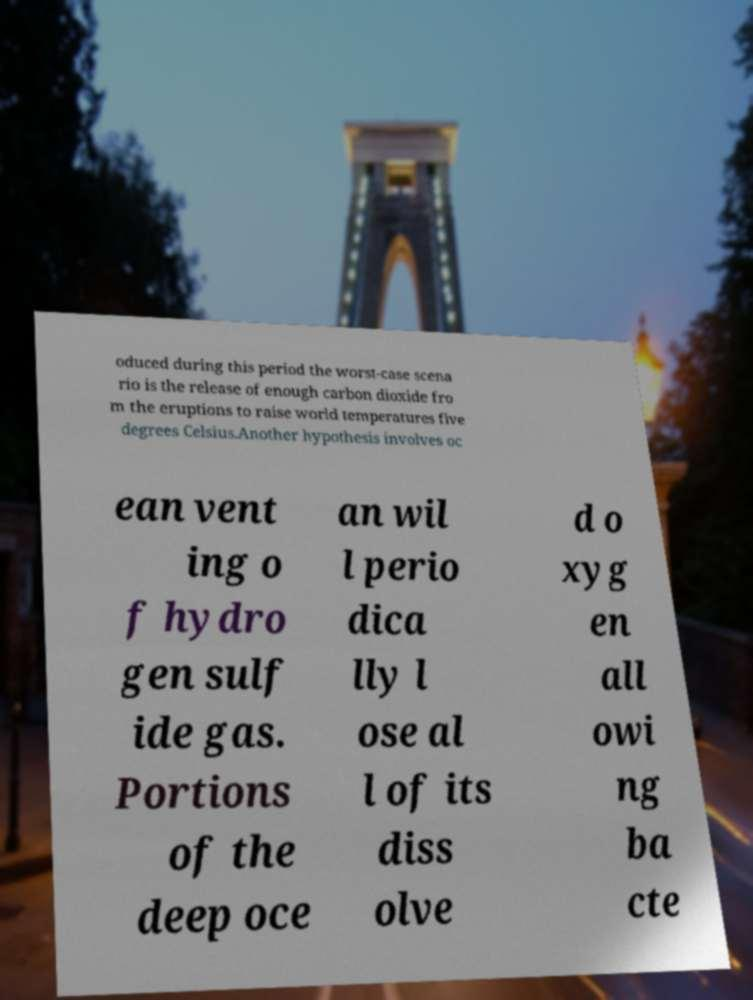There's text embedded in this image that I need extracted. Can you transcribe it verbatim? oduced during this period the worst-case scena rio is the release of enough carbon dioxide fro m the eruptions to raise world temperatures five degrees Celsius.Another hypothesis involves oc ean vent ing o f hydro gen sulf ide gas. Portions of the deep oce an wil l perio dica lly l ose al l of its diss olve d o xyg en all owi ng ba cte 